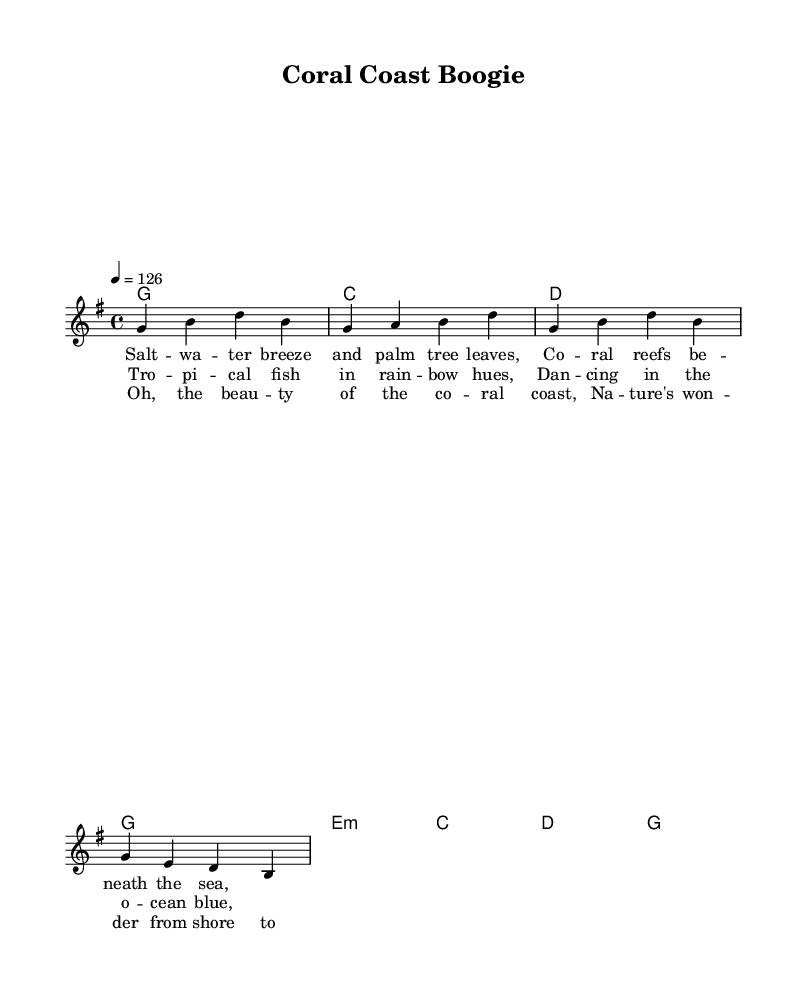What is the key signature of this music? The key signature is G major, which has one sharp. This can be identified at the beginning of the staff, indicating that F# is meant to be played sharp throughout the piece.
Answer: G major What is the time signature of this music? The time signature is 4/4, which is indicated right after the key signature. This means that there are four beats per measure and the quarter note receives one beat.
Answer: 4/4 What is the tempo marking of this music? The tempo marking is quarter note equals 126 beats per minute. This is shown in the score where it specifies the speed of the music, indicating how fast the piece should be played.
Answer: 126 How many measures are there in the melody? The melody consists of 8 measures, which can be counted by the number of sets of bar lines present in the melody staff. Each section of melody ends with a bar line that signifies the end of a measure.
Answer: 8 measures Which chords are used in the harmonies? The chords used in the harmonies are G, C, D, and E minor. These are laid out in the chord mode section of the score, indicating the chord changes that correspond with the melody.
Answer: G, C, D, E minor What is the main theme reflected in the lyrics? The main theme reflected in the lyrics is the beauty of coral coastlines and tropical nature. The lyrics describe aspects of nature, such as saltwater and coral reefs, celebrating the coastal environment.
Answer: Beauty of coral coastlines How does the structure of this piece exemplify country rock? The structure features a catchy melody and simple chord progressions typical of country rock. Additionally, the lively tempo and upbeat lyrics celebrate nature, aligning with the genre's characteristics of storytelling and celebration of life.
Answer: Catchy melody and simple chords 